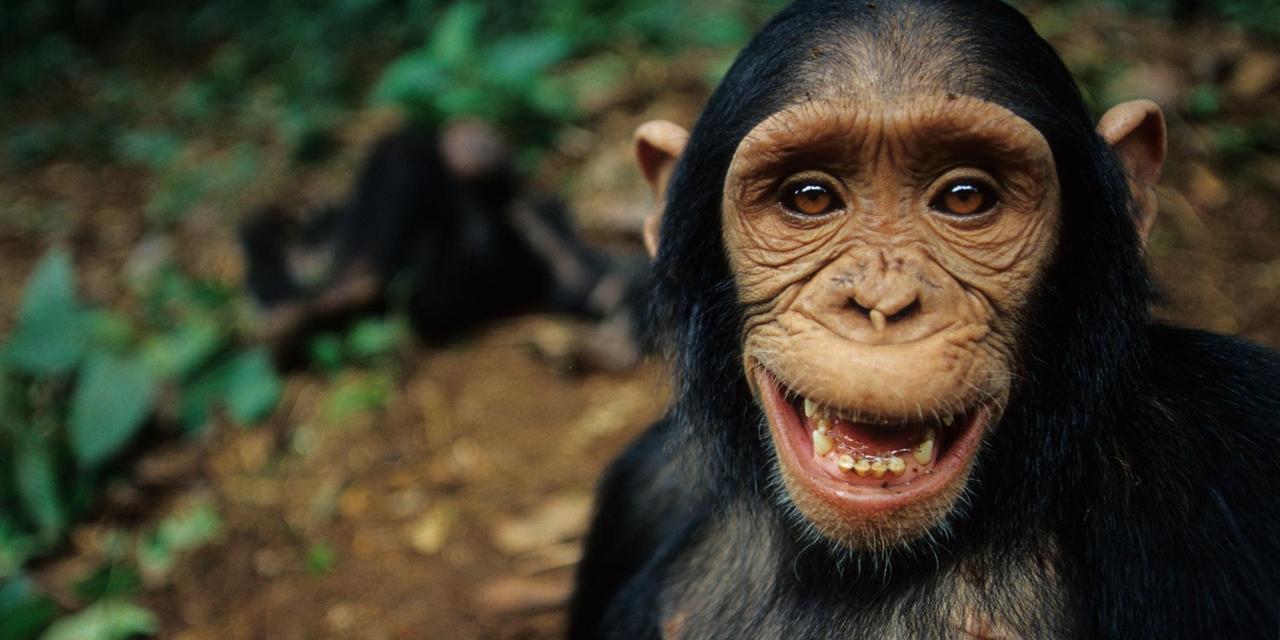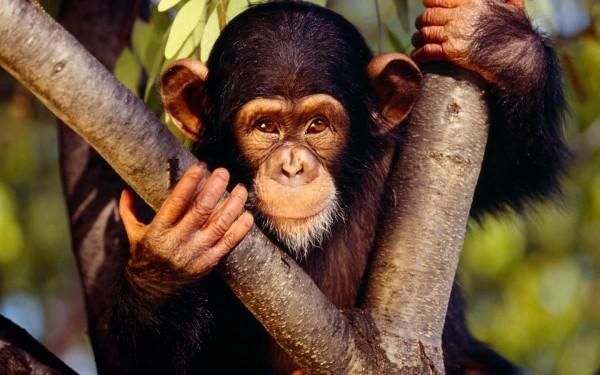The first image is the image on the left, the second image is the image on the right. Considering the images on both sides, is "In one of the images, a young chimp places something in its mouth." valid? Answer yes or no. No. The first image is the image on the left, the second image is the image on the right. Examine the images to the left and right. Is the description "A small monkey eats leaves." accurate? Answer yes or no. No. 